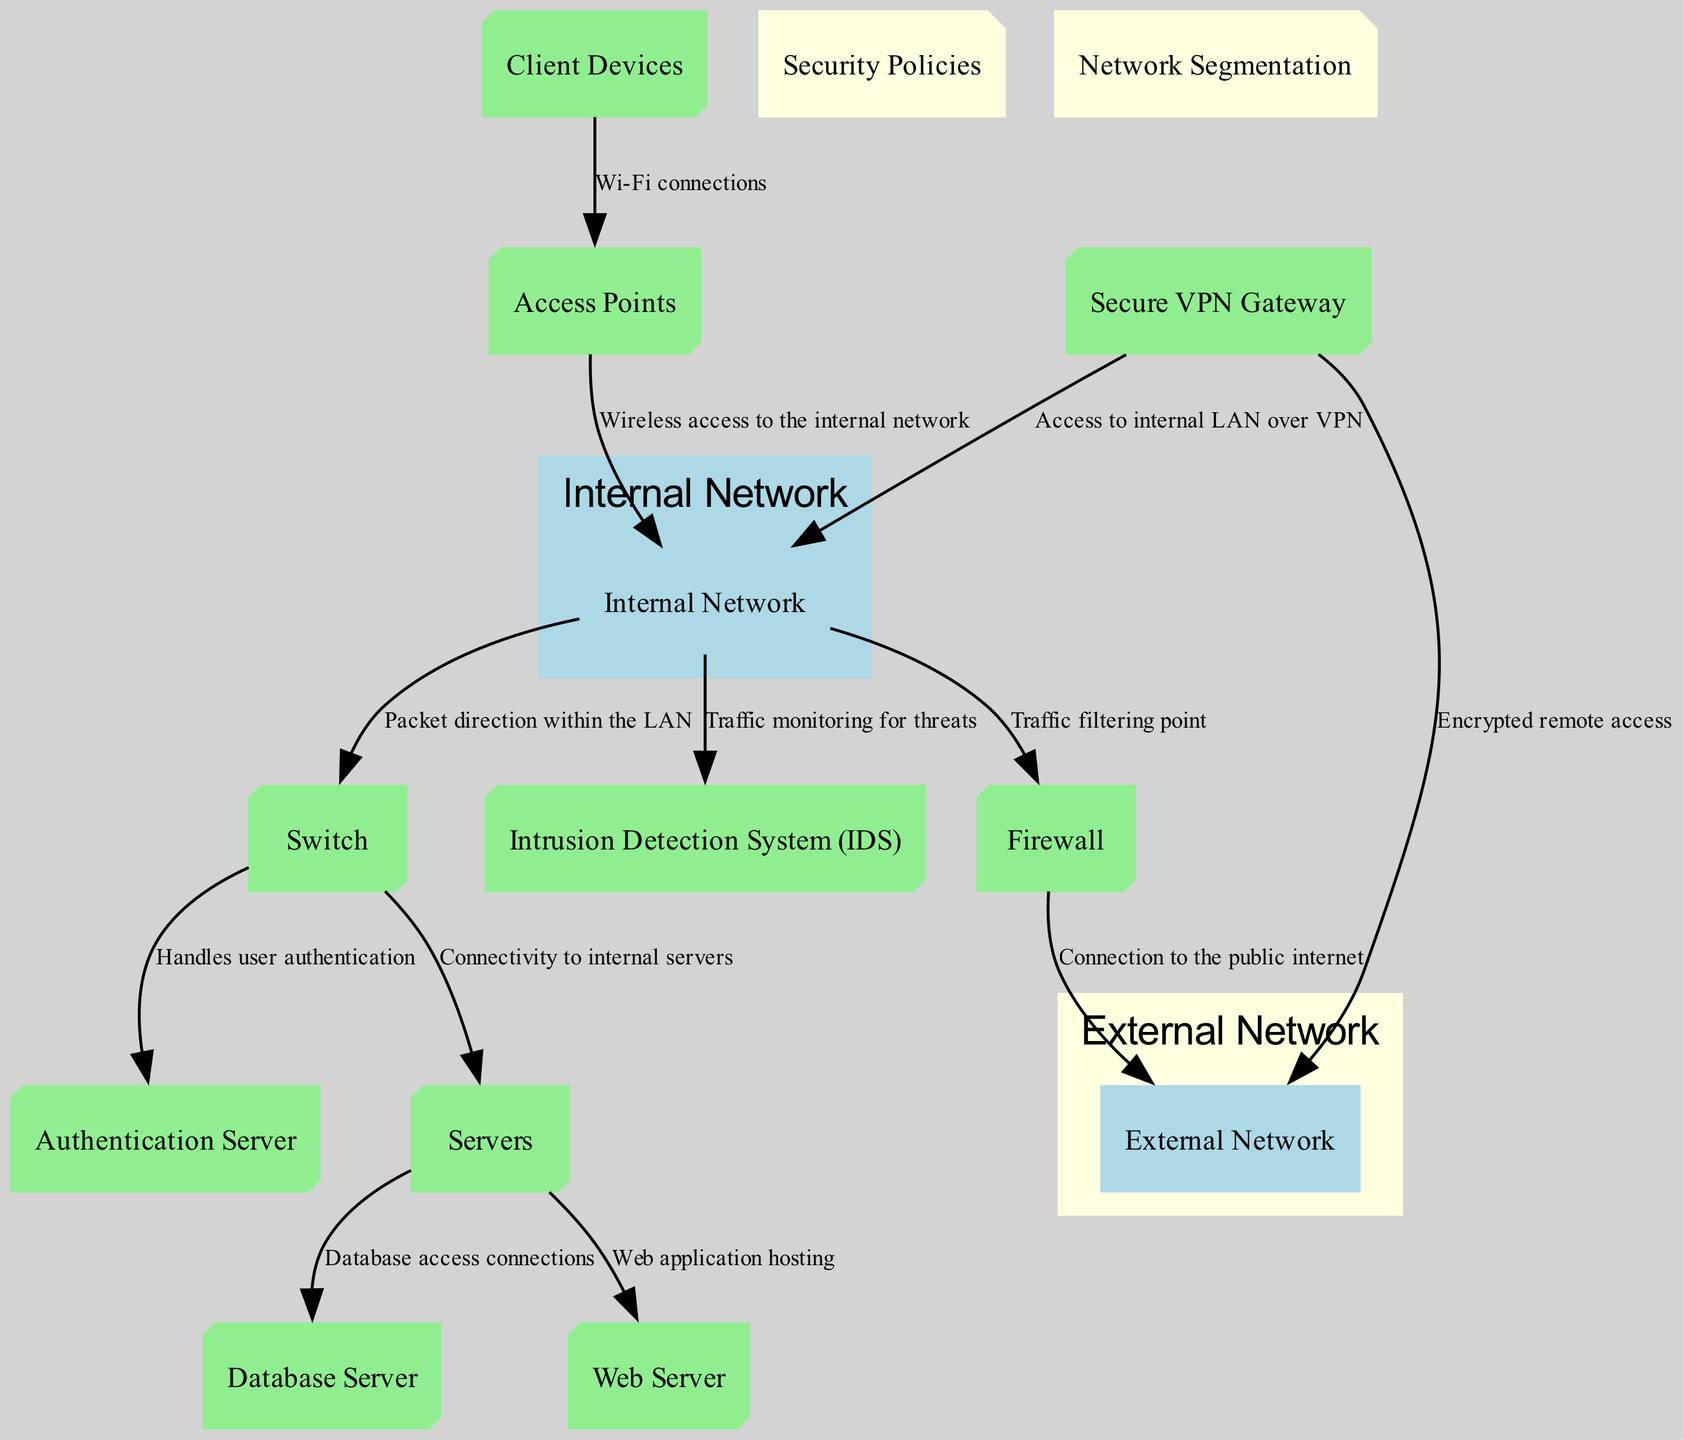What type of device is the Firewall? The Firewall is categorized as a "device" in the diagram. It is specifically used to filter incoming and outgoing network traffic based on security rules.
Answer: device How do Client Devices connect to the network? Client Devices connect to the network through Access Points using Wi-Fi connections, as indicated by the connection line between them.
Answer: Wi-Fi connections What does the Intrusion Detection System monitor? The Intrusion Detection System (IDS) monitors network traffic for suspicious activity and potential threats, as described in its definition on the diagram.
Answer: network traffic How many servers are illustrated in the diagram? In the diagram, there are three types of servers: Database Server, Web Server, and a general Servers node. These are represented as three separate nodes.
Answer: three What is the purpose of the Secure VPN Gateway? The Secure VPN Gateway enables secure remote access to the network over encrypted tunnels, as described in its section of the diagram.
Answer: secure remote access How does the Firewall connect to the External Network? The Firewall connects to the External Network as it acts as the traffic filtering point for connections going out and coming in from the public internet, represented by a directed edge.
Answer: connection What type of configuration is Network Segmentation? Network Segmentation is classified as a "config" in the diagram. It refers to the practice of dividing the network into segments to enhance security and performance.
Answer: config Which node handles user authentication? The Authentication Server is responsible for handling user authentication requests, typically using protocols like RADIUS or LDAP as noted in its description.
Answer: Authentication Server What is a key function of the Access Points in the diagram? Access Points provide wireless connectivity to the network for Client Devices, facilitating the connection of various devices without physical cables.
Answer: wireless connectivity 